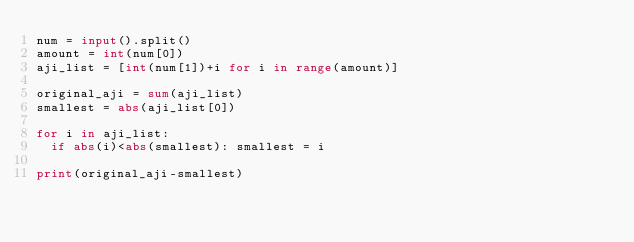Convert code to text. <code><loc_0><loc_0><loc_500><loc_500><_Python_>num = input().split()
amount = int(num[0])
aji_list = [int(num[1])+i for i in range(amount)]

original_aji = sum(aji_list)
smallest = abs(aji_list[0])

for i in aji_list:
  if abs(i)<abs(smallest): smallest = i
    
print(original_aji-smallest)</code> 